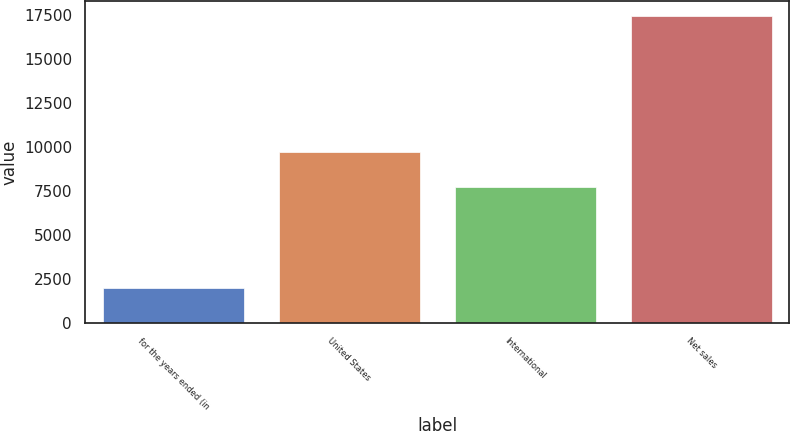Convert chart. <chart><loc_0><loc_0><loc_500><loc_500><bar_chart><fcel>for the years ended (in<fcel>United States<fcel>International<fcel>Net sales<nl><fcel>2011<fcel>9712<fcel>7732<fcel>17444<nl></chart> 